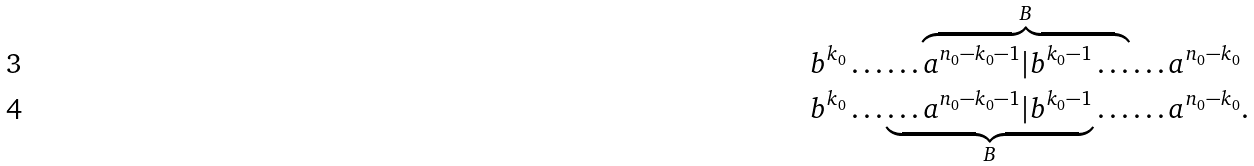Convert formula to latex. <formula><loc_0><loc_0><loc_500><loc_500>& b ^ { k _ { 0 } } \dots \dots \overbrace { a ^ { n _ { 0 } - k _ { 0 } - 1 } | b ^ { k _ { 0 } - 1 } \dots } ^ { B } \dots a ^ { n _ { 0 } - k _ { 0 } } \\ & b ^ { k _ { 0 } } \dots \underbrace { \dots a ^ { n _ { 0 } - k _ { 0 } - 1 } | b ^ { k _ { 0 } - 1 } } _ { B } \dots \dots a ^ { n _ { 0 } - k _ { 0 } } .</formula> 